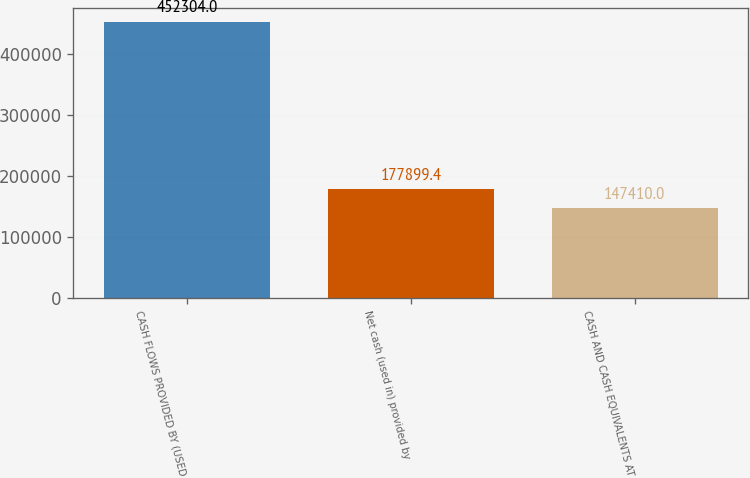<chart> <loc_0><loc_0><loc_500><loc_500><bar_chart><fcel>CASH FLOWS PROVIDED BY (USED<fcel>Net cash (used in) provided by<fcel>CASH AND CASH EQUIVALENTS AT<nl><fcel>452304<fcel>177899<fcel>147410<nl></chart> 